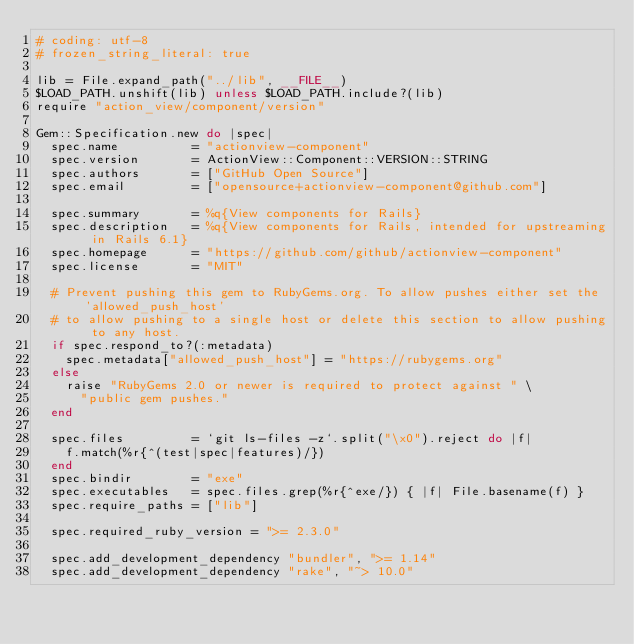Convert code to text. <code><loc_0><loc_0><loc_500><loc_500><_Ruby_># coding: utf-8
# frozen_string_literal: true

lib = File.expand_path("../lib", __FILE__)
$LOAD_PATH.unshift(lib) unless $LOAD_PATH.include?(lib)
require "action_view/component/version"

Gem::Specification.new do |spec|
  spec.name          = "actionview-component"
  spec.version       = ActionView::Component::VERSION::STRING
  spec.authors       = ["GitHub Open Source"]
  spec.email         = ["opensource+actionview-component@github.com"]

  spec.summary       = %q{View components for Rails}
  spec.description   = %q{View components for Rails, intended for upstreaming in Rails 6.1}
  spec.homepage      = "https://github.com/github/actionview-component"
  spec.license       = "MIT"

  # Prevent pushing this gem to RubyGems.org. To allow pushes either set the 'allowed_push_host'
  # to allow pushing to a single host or delete this section to allow pushing to any host.
  if spec.respond_to?(:metadata)
    spec.metadata["allowed_push_host"] = "https://rubygems.org"
  else
    raise "RubyGems 2.0 or newer is required to protect against " \
      "public gem pushes."
  end

  spec.files         = `git ls-files -z`.split("\x0").reject do |f|
    f.match(%r{^(test|spec|features)/})
  end
  spec.bindir        = "exe"
  spec.executables   = spec.files.grep(%r{^exe/}) { |f| File.basename(f) }
  spec.require_paths = ["lib"]

  spec.required_ruby_version = ">= 2.3.0"

  spec.add_development_dependency "bundler", ">= 1.14"
  spec.add_development_dependency "rake", "~> 10.0"</code> 